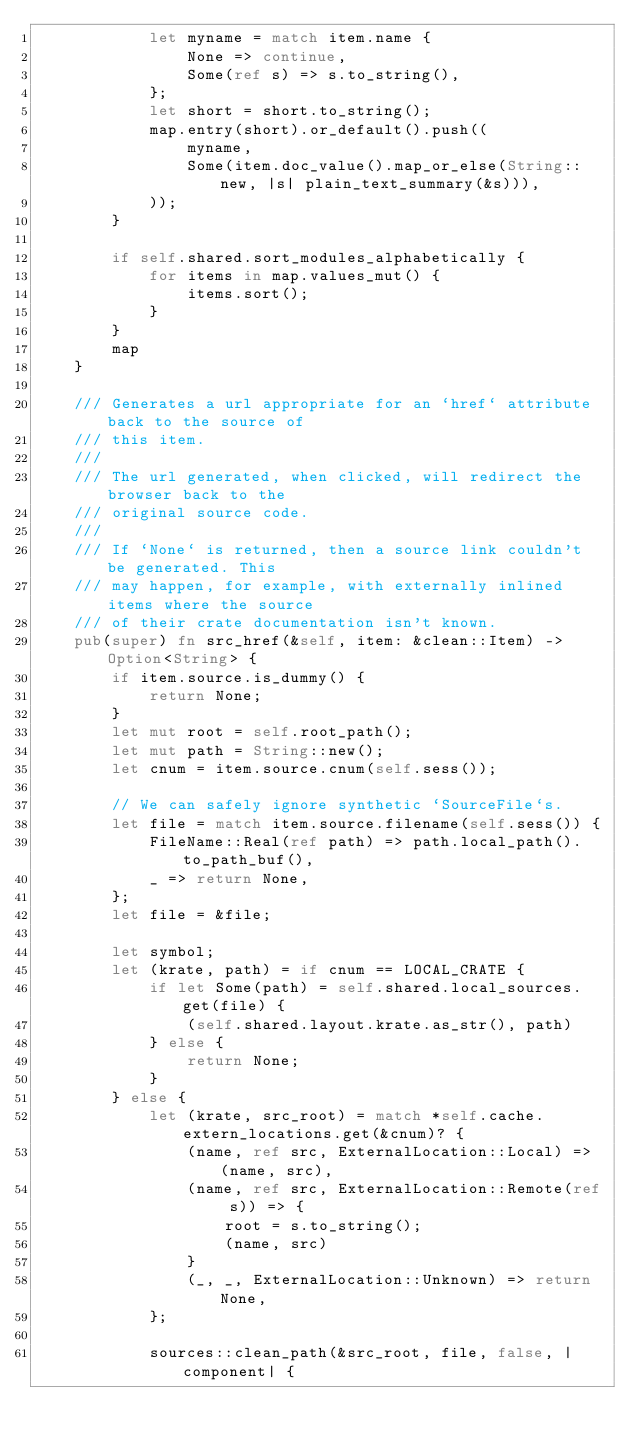Convert code to text. <code><loc_0><loc_0><loc_500><loc_500><_Rust_>            let myname = match item.name {
                None => continue,
                Some(ref s) => s.to_string(),
            };
            let short = short.to_string();
            map.entry(short).or_default().push((
                myname,
                Some(item.doc_value().map_or_else(String::new, |s| plain_text_summary(&s))),
            ));
        }

        if self.shared.sort_modules_alphabetically {
            for items in map.values_mut() {
                items.sort();
            }
        }
        map
    }

    /// Generates a url appropriate for an `href` attribute back to the source of
    /// this item.
    ///
    /// The url generated, when clicked, will redirect the browser back to the
    /// original source code.
    ///
    /// If `None` is returned, then a source link couldn't be generated. This
    /// may happen, for example, with externally inlined items where the source
    /// of their crate documentation isn't known.
    pub(super) fn src_href(&self, item: &clean::Item) -> Option<String> {
        if item.source.is_dummy() {
            return None;
        }
        let mut root = self.root_path();
        let mut path = String::new();
        let cnum = item.source.cnum(self.sess());

        // We can safely ignore synthetic `SourceFile`s.
        let file = match item.source.filename(self.sess()) {
            FileName::Real(ref path) => path.local_path().to_path_buf(),
            _ => return None,
        };
        let file = &file;

        let symbol;
        let (krate, path) = if cnum == LOCAL_CRATE {
            if let Some(path) = self.shared.local_sources.get(file) {
                (self.shared.layout.krate.as_str(), path)
            } else {
                return None;
            }
        } else {
            let (krate, src_root) = match *self.cache.extern_locations.get(&cnum)? {
                (name, ref src, ExternalLocation::Local) => (name, src),
                (name, ref src, ExternalLocation::Remote(ref s)) => {
                    root = s.to_string();
                    (name, src)
                }
                (_, _, ExternalLocation::Unknown) => return None,
            };

            sources::clean_path(&src_root, file, false, |component| {</code> 